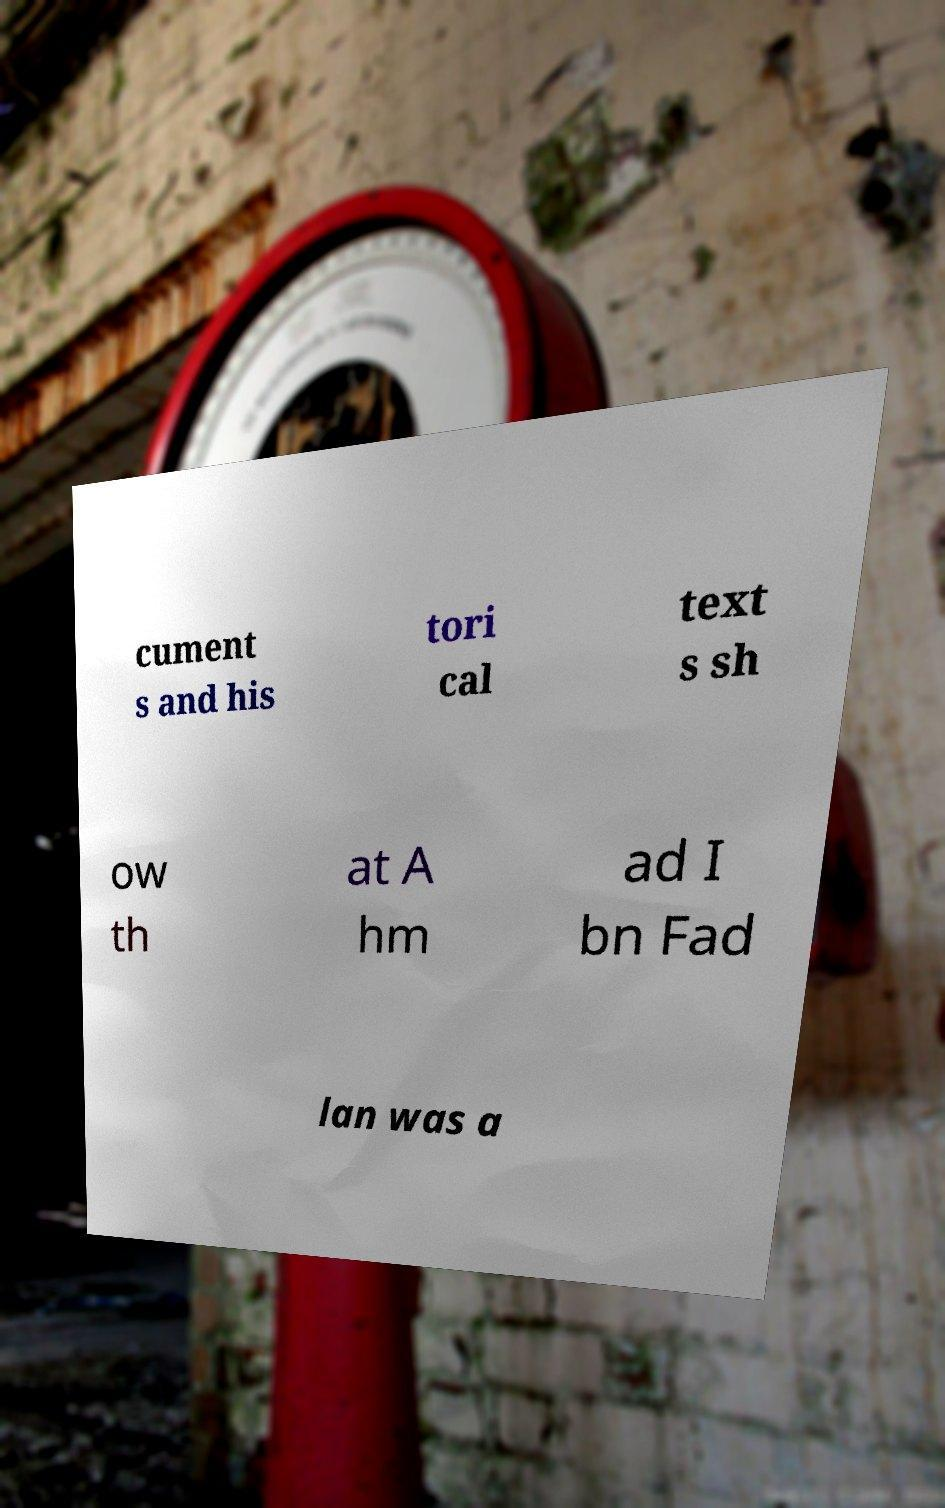There's text embedded in this image that I need extracted. Can you transcribe it verbatim? cument s and his tori cal text s sh ow th at A hm ad I bn Fad lan was a 